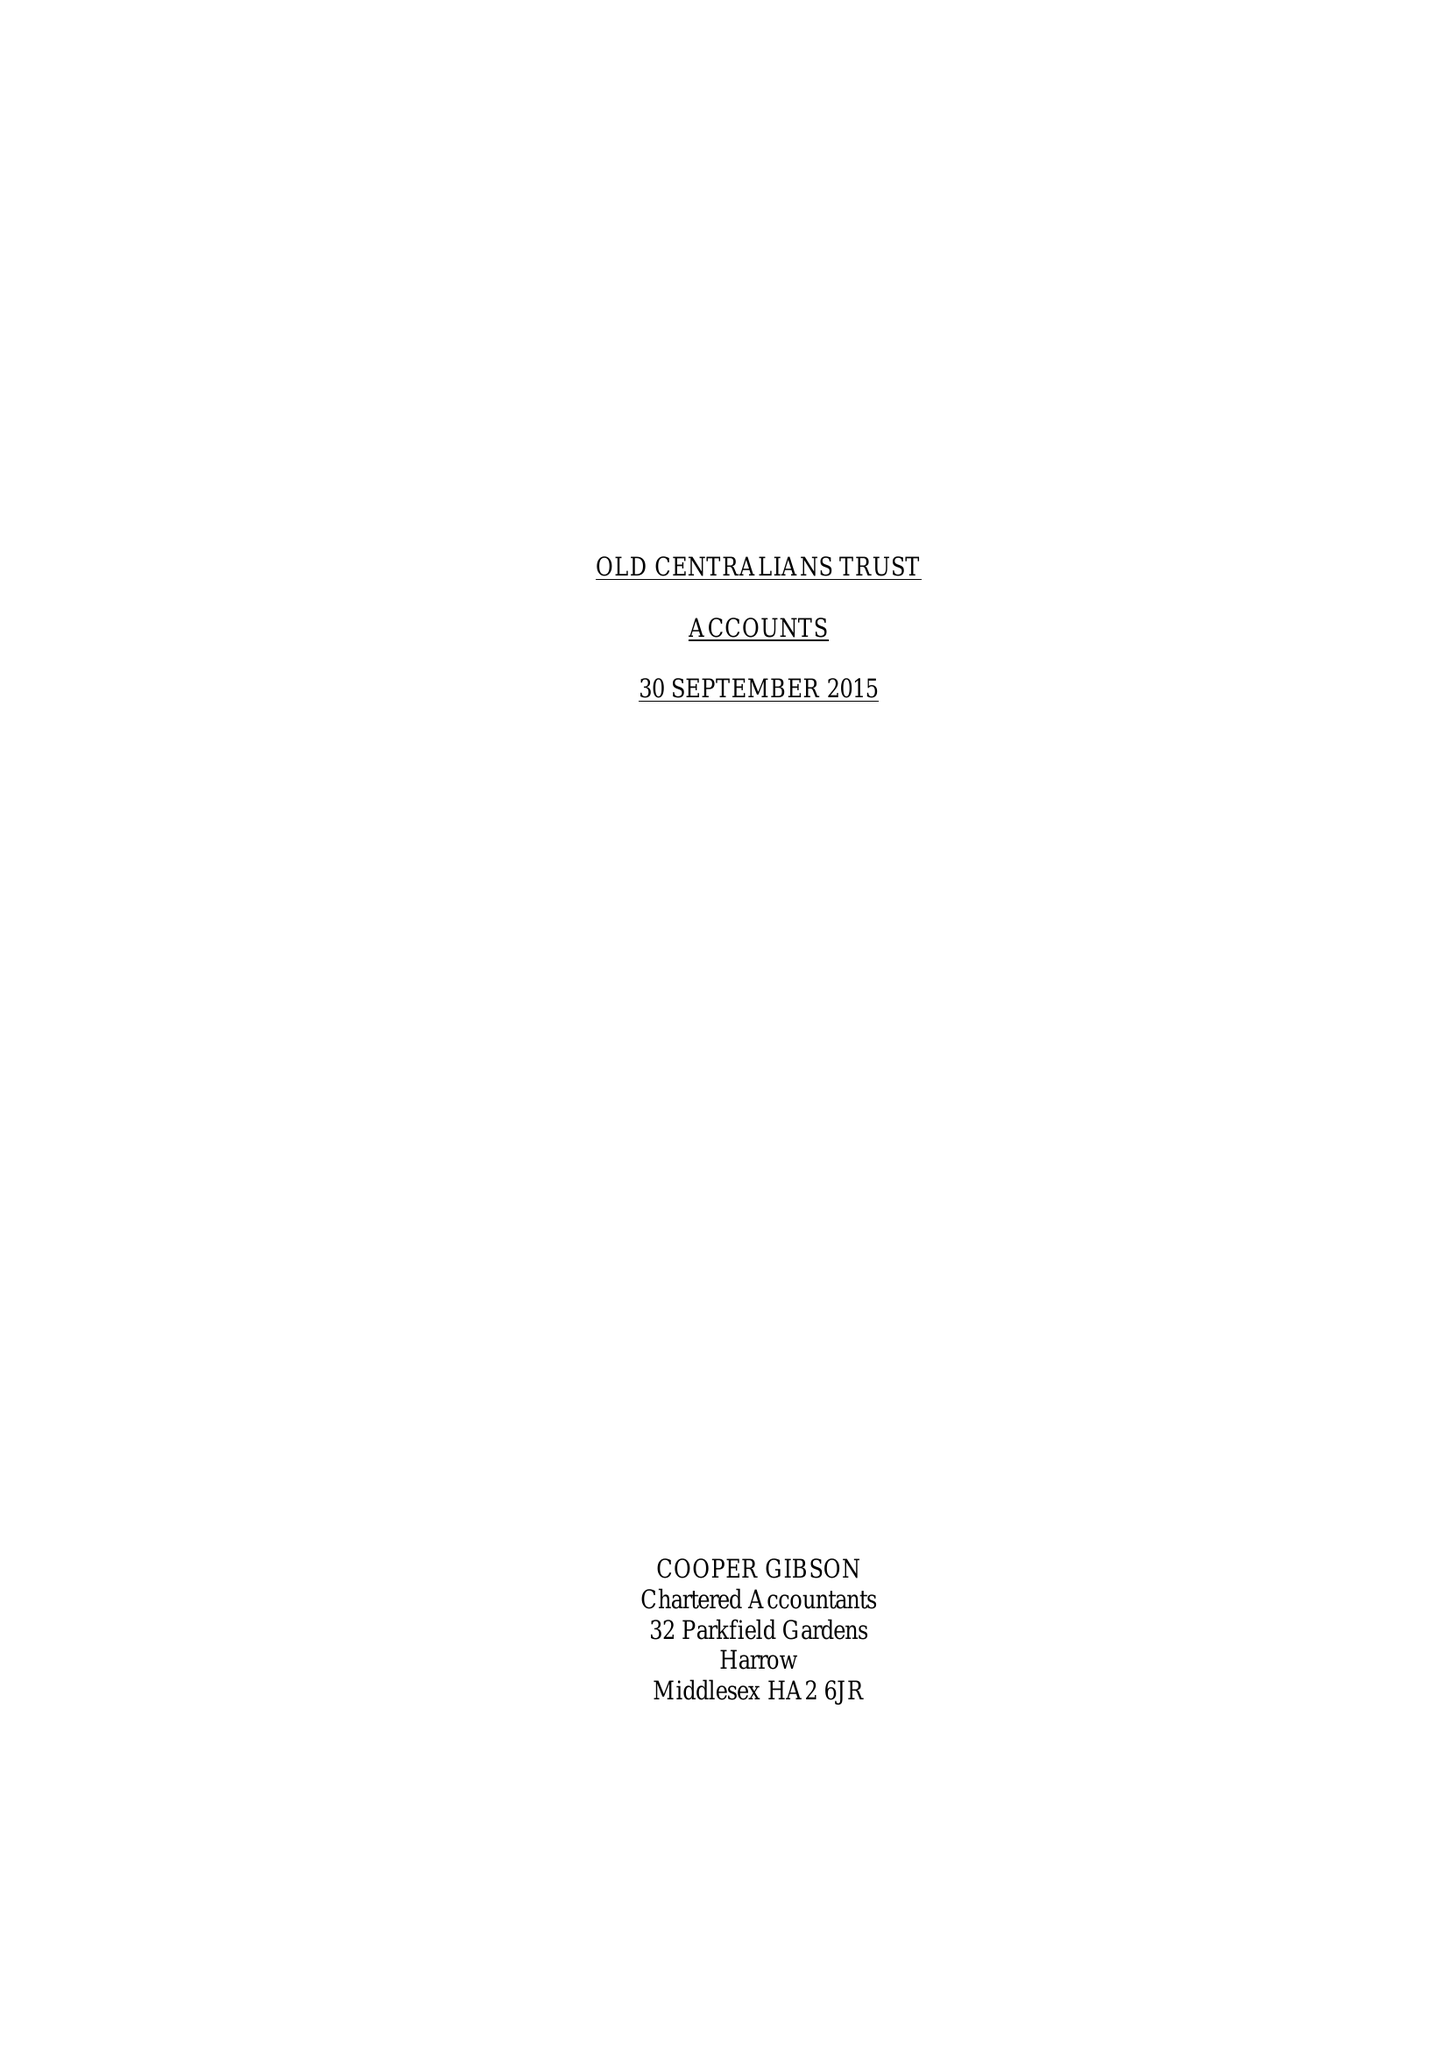What is the value for the address__postcode?
Answer the question using a single word or phrase. SW7 2AZ 